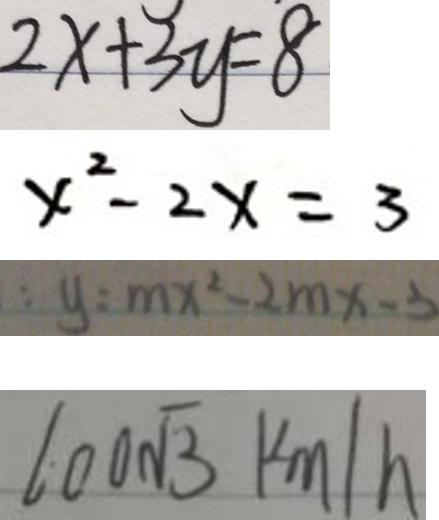Convert formula to latex. <formula><loc_0><loc_0><loc_500><loc_500>2 x + 3 y = 8 
 x ^ { 2 } - 2 x = 3 
 : y : m x ^ { 2 } - 2 m x - 3 
 1 0 0 \sqrt { 3 } k m / h</formula> 